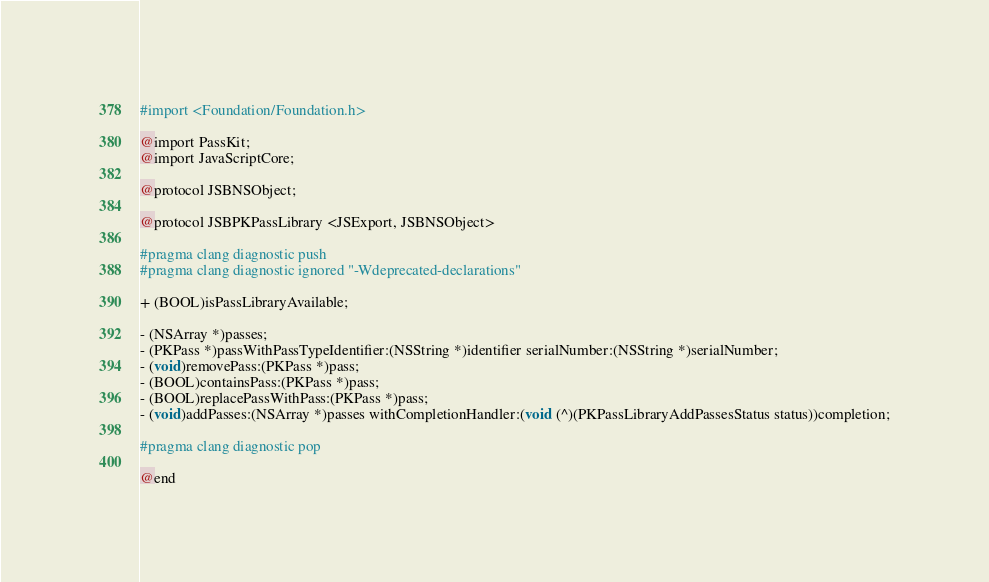Convert code to text. <code><loc_0><loc_0><loc_500><loc_500><_C_>#import <Foundation/Foundation.h>

@import PassKit;
@import JavaScriptCore;

@protocol JSBNSObject;

@protocol JSBPKPassLibrary <JSExport, JSBNSObject>

#pragma clang diagnostic push
#pragma clang diagnostic ignored "-Wdeprecated-declarations"

+ (BOOL)isPassLibraryAvailable;

- (NSArray *)passes;
- (PKPass *)passWithPassTypeIdentifier:(NSString *)identifier serialNumber:(NSString *)serialNumber;
- (void)removePass:(PKPass *)pass;
- (BOOL)containsPass:(PKPass *)pass;
- (BOOL)replacePassWithPass:(PKPass *)pass;
- (void)addPasses:(NSArray *)passes withCompletionHandler:(void (^)(PKPassLibraryAddPassesStatus status))completion;

#pragma clang diagnostic pop

@end
</code> 